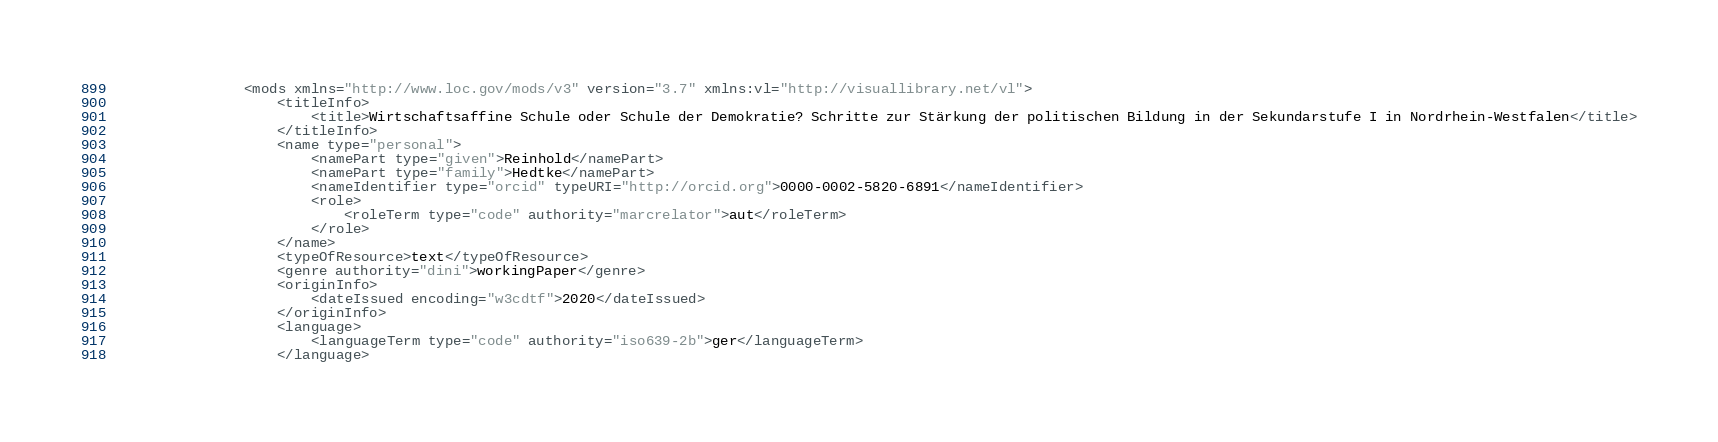<code> <loc_0><loc_0><loc_500><loc_500><_XML_>                <mods xmlns="http://www.loc.gov/mods/v3" version="3.7" xmlns:vl="http://visuallibrary.net/vl">
                    <titleInfo>
                        <title>Wirtschaftsaffine Schule oder Schule der Demokratie? Schritte zur Stärkung der politischen Bildung in der Sekundarstufe I in Nordrhein-Westfalen</title>
                    </titleInfo>
                    <name type="personal">
                        <namePart type="given">Reinhold</namePart>
                        <namePart type="family">Hedtke</namePart>
                        <nameIdentifier type="orcid" typeURI="http://orcid.org">0000-0002-5820-6891</nameIdentifier>
                        <role>
                            <roleTerm type="code" authority="marcrelator">aut</roleTerm>
                        </role>
                    </name>
                    <typeOfResource>text</typeOfResource>
                    <genre authority="dini">workingPaper</genre>
                    <originInfo>
                        <dateIssued encoding="w3cdtf">2020</dateIssued>
                    </originInfo>
                    <language>
                        <languageTerm type="code" authority="iso639-2b">ger</languageTerm>
                    </language></code> 